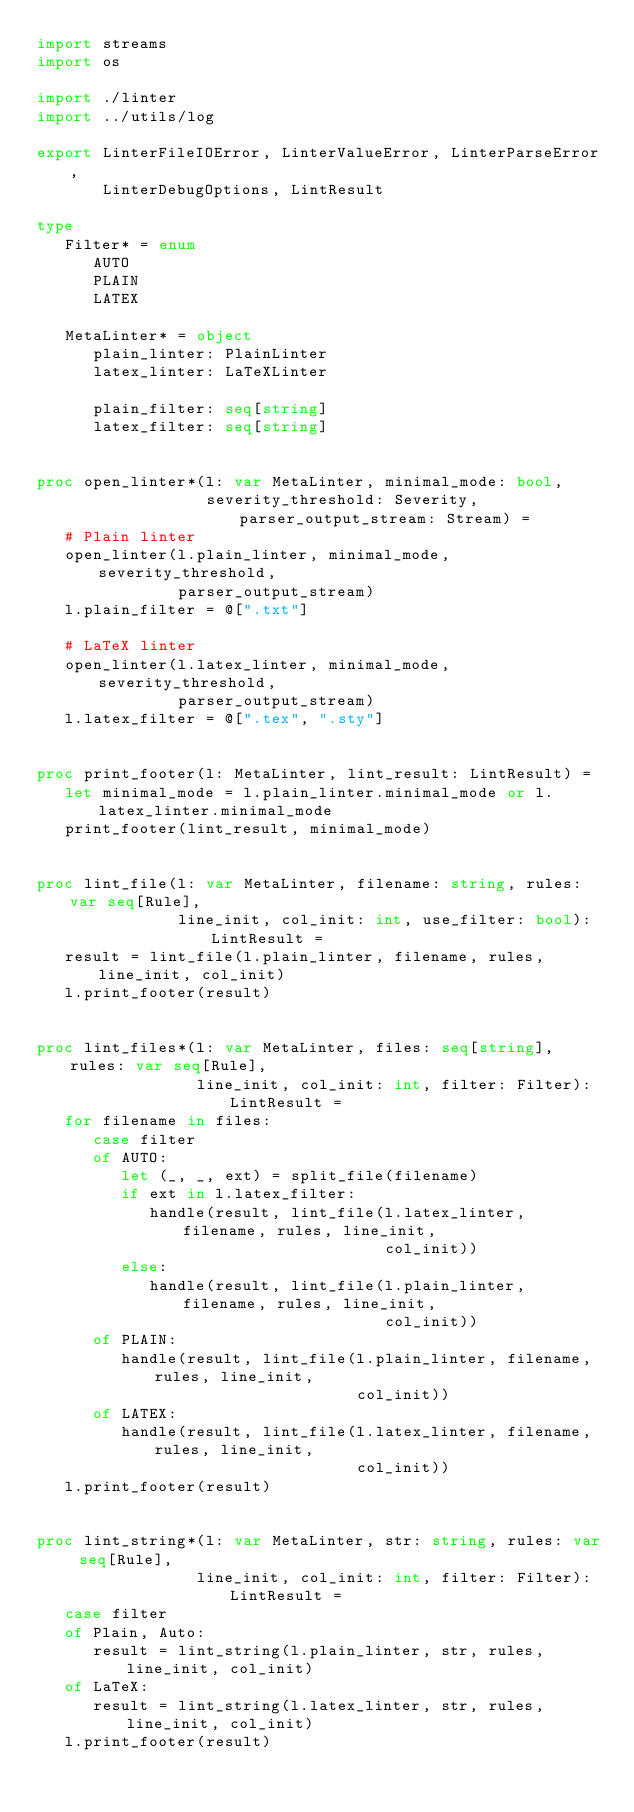<code> <loc_0><loc_0><loc_500><loc_500><_Nim_>import streams
import os

import ./linter
import ../utils/log

export LinterFileIOError, LinterValueError, LinterParseError,
       LinterDebugOptions, LintResult

type
   Filter* = enum
      AUTO
      PLAIN
      LATEX

   MetaLinter* = object
      plain_linter: PlainLinter
      latex_linter: LaTeXLinter

      plain_filter: seq[string]
      latex_filter: seq[string]


proc open_linter*(l: var MetaLinter, minimal_mode: bool,
                  severity_threshold: Severity, parser_output_stream: Stream) =
   # Plain linter
   open_linter(l.plain_linter, minimal_mode, severity_threshold,
               parser_output_stream)
   l.plain_filter = @[".txt"]

   # LaTeX linter
   open_linter(l.latex_linter, minimal_mode, severity_threshold,
               parser_output_stream)
   l.latex_filter = @[".tex", ".sty"]


proc print_footer(l: MetaLinter, lint_result: LintResult) =
   let minimal_mode = l.plain_linter.minimal_mode or l.latex_linter.minimal_mode
   print_footer(lint_result, minimal_mode)


proc lint_file(l: var MetaLinter, filename: string, rules: var seq[Rule],
               line_init, col_init: int, use_filter: bool): LintResult =
   result = lint_file(l.plain_linter, filename, rules, line_init, col_init)
   l.print_footer(result)


proc lint_files*(l: var MetaLinter, files: seq[string], rules: var seq[Rule],
                 line_init, col_init: int, filter: Filter): LintResult =
   for filename in files:
      case filter
      of AUTO:
         let (_, _, ext) = split_file(filename)
         if ext in l.latex_filter:
            handle(result, lint_file(l.latex_linter, filename, rules, line_init,
                                     col_init))
         else:
            handle(result, lint_file(l.plain_linter, filename, rules, line_init,
                                     col_init))
      of PLAIN:
         handle(result, lint_file(l.plain_linter, filename, rules, line_init,
                                  col_init))
      of LATEX:
         handle(result, lint_file(l.latex_linter, filename, rules, line_init,
                                  col_init))
   l.print_footer(result)


proc lint_string*(l: var MetaLinter, str: string, rules: var seq[Rule],
                 line_init, col_init: int, filter: Filter): LintResult =
   case filter
   of Plain, Auto:
      result = lint_string(l.plain_linter, str, rules, line_init, col_init)
   of LaTeX:
      result = lint_string(l.latex_linter, str, rules, line_init, col_init)
   l.print_footer(result)
</code> 